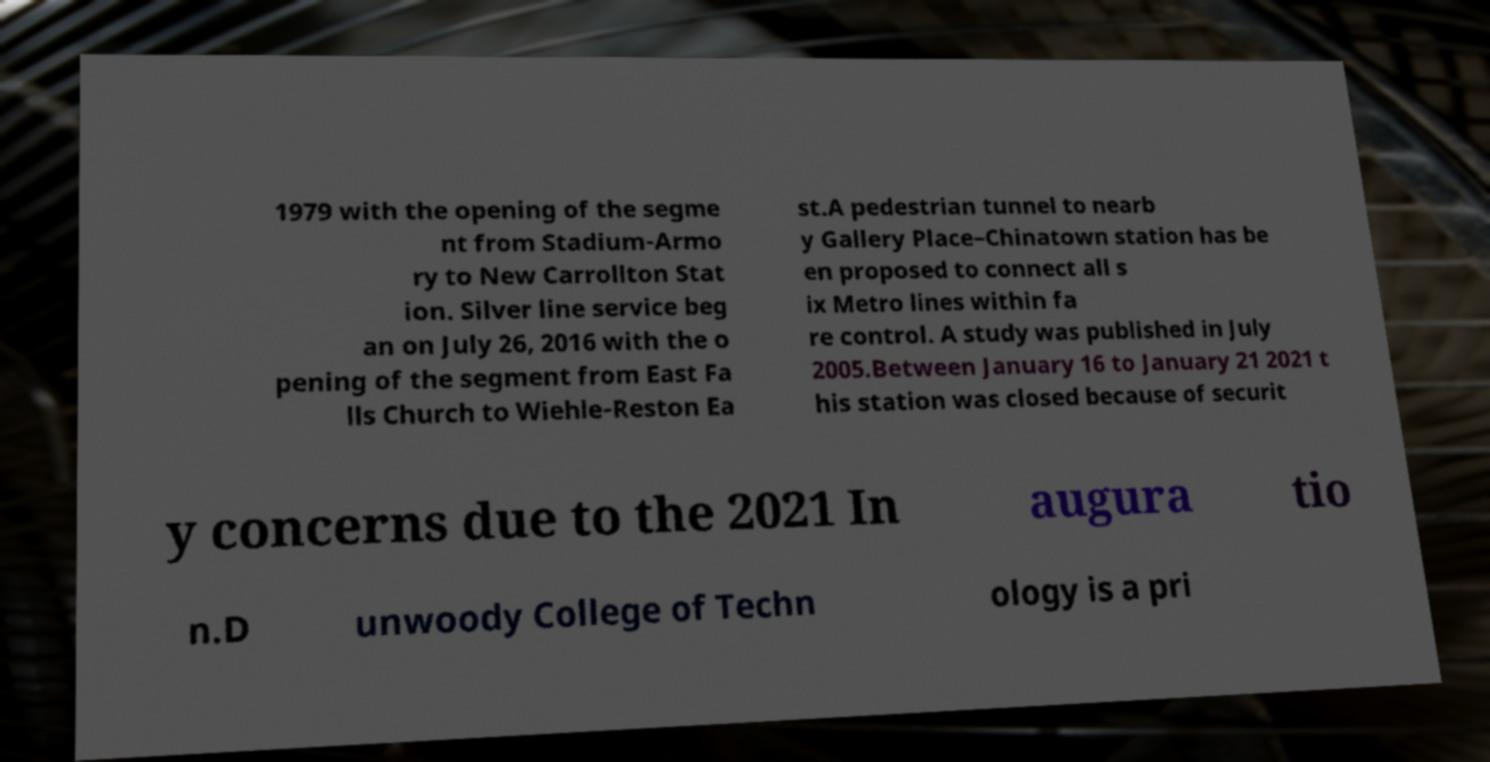Can you read and provide the text displayed in the image?This photo seems to have some interesting text. Can you extract and type it out for me? 1979 with the opening of the segme nt from Stadium-Armo ry to New Carrollton Stat ion. Silver line service beg an on July 26, 2016 with the o pening of the segment from East Fa lls Church to Wiehle-Reston Ea st.A pedestrian tunnel to nearb y Gallery Place–Chinatown station has be en proposed to connect all s ix Metro lines within fa re control. A study was published in July 2005.Between January 16 to January 21 2021 t his station was closed because of securit y concerns due to the 2021 In augura tio n.D unwoody College of Techn ology is a pri 